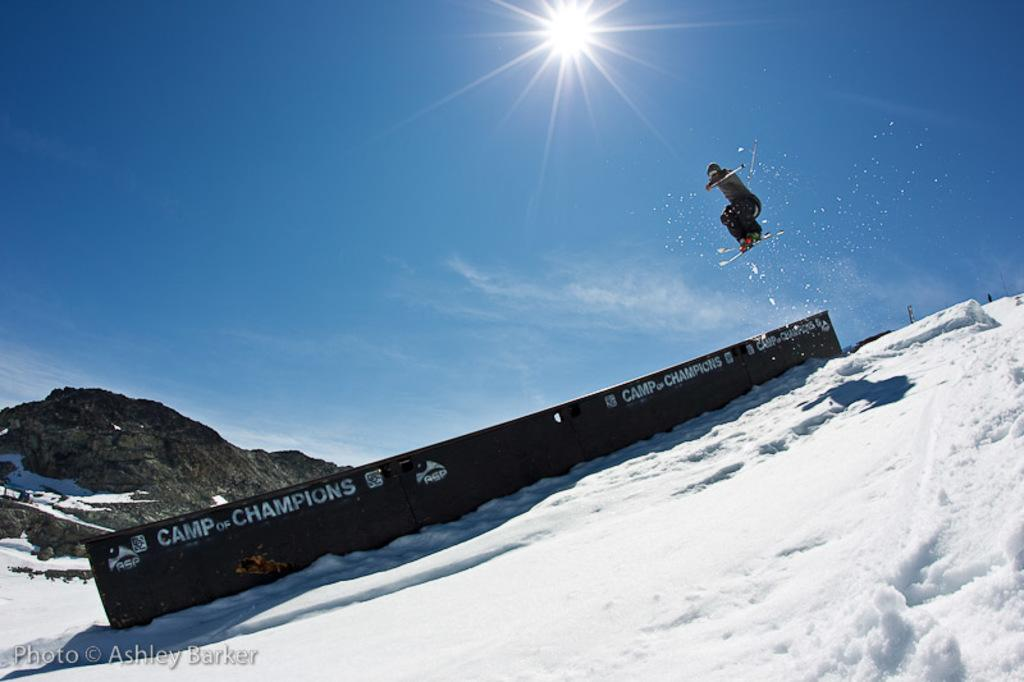Provide a one-sentence caption for the provided image. A skier is in the air above a ramp that says Camp of Champions. 